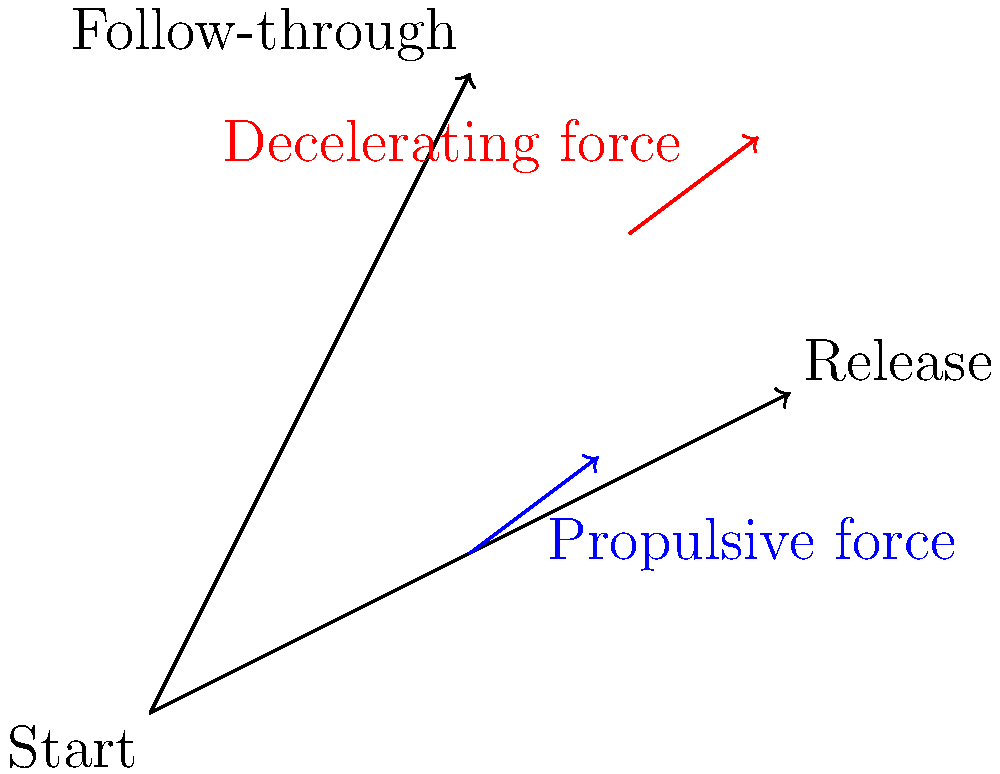In the biomechanics of throwing a ball, which phase of the throw generates the most propulsive force, and how does this relate to the principle of summation of forces? Refer to the diagram showing arm positions and force vectors. To answer this question, let's break down the throwing motion and analyze the forces involved:

1. Start position: The arm is cocked back, preparing for the throw.

2. Release position: This is where the most propulsive force is generated. The blue arrow in the diagram represents this force.

3. Follow-through: After release, a decelerating force (red arrow) acts to slow down the arm.

The principle of summation of forces states that the total force acting on an object is the sum of all individual forces. In throwing, this principle is applied as follows:

a) The throw begins with the legs and trunk, generating initial momentum.
b) As the motion progresses to the upper body, the shoulder begins to rotate.
c) The elbow extends, adding to the force.
d) Finally, the wrist snaps, providing the last boost of force.

Each segment's force adds to the previous ones, resulting in a cumulative effect that produces maximum velocity at the point of release. This is why the propulsive force (blue arrow) is shown at its largest just before the release position.

The follow-through phase helps to safely decelerate the arm after release, preventing injury. The red arrow represents this decelerating force.

Understanding this biomechanical principle can help improve throwing technique and performance, which could be relevant for organizing sports events or physical education initiatives as a class president.
Answer: The release phase generates the most propulsive force, utilizing the principle of summation of forces from legs, trunk, shoulder, elbow, and wrist. 